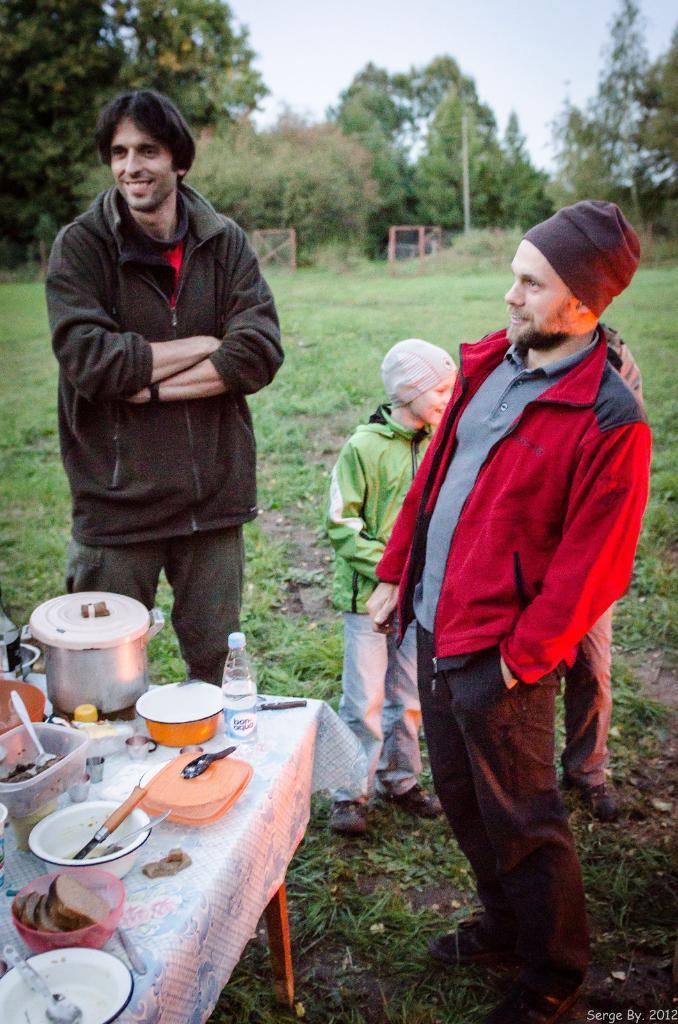In one or two sentences, can you explain what this image depicts? As we can see in the image there is a sky, trees, grass, three people standing over here and there is a table. On table there is a cooker, bowl, spoons, box and bottle. 